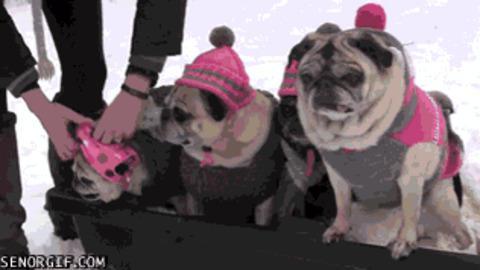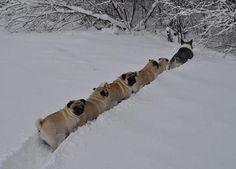The first image is the image on the left, the second image is the image on the right. Examine the images to the left and right. Is the description "There are exactly 8 pugs sitting in a sled wearing hats." accurate? Answer yes or no. No. The first image is the image on the left, the second image is the image on the right. Given the left and right images, does the statement "there is a human in the image on the left" hold true? Answer yes or no. Yes. 